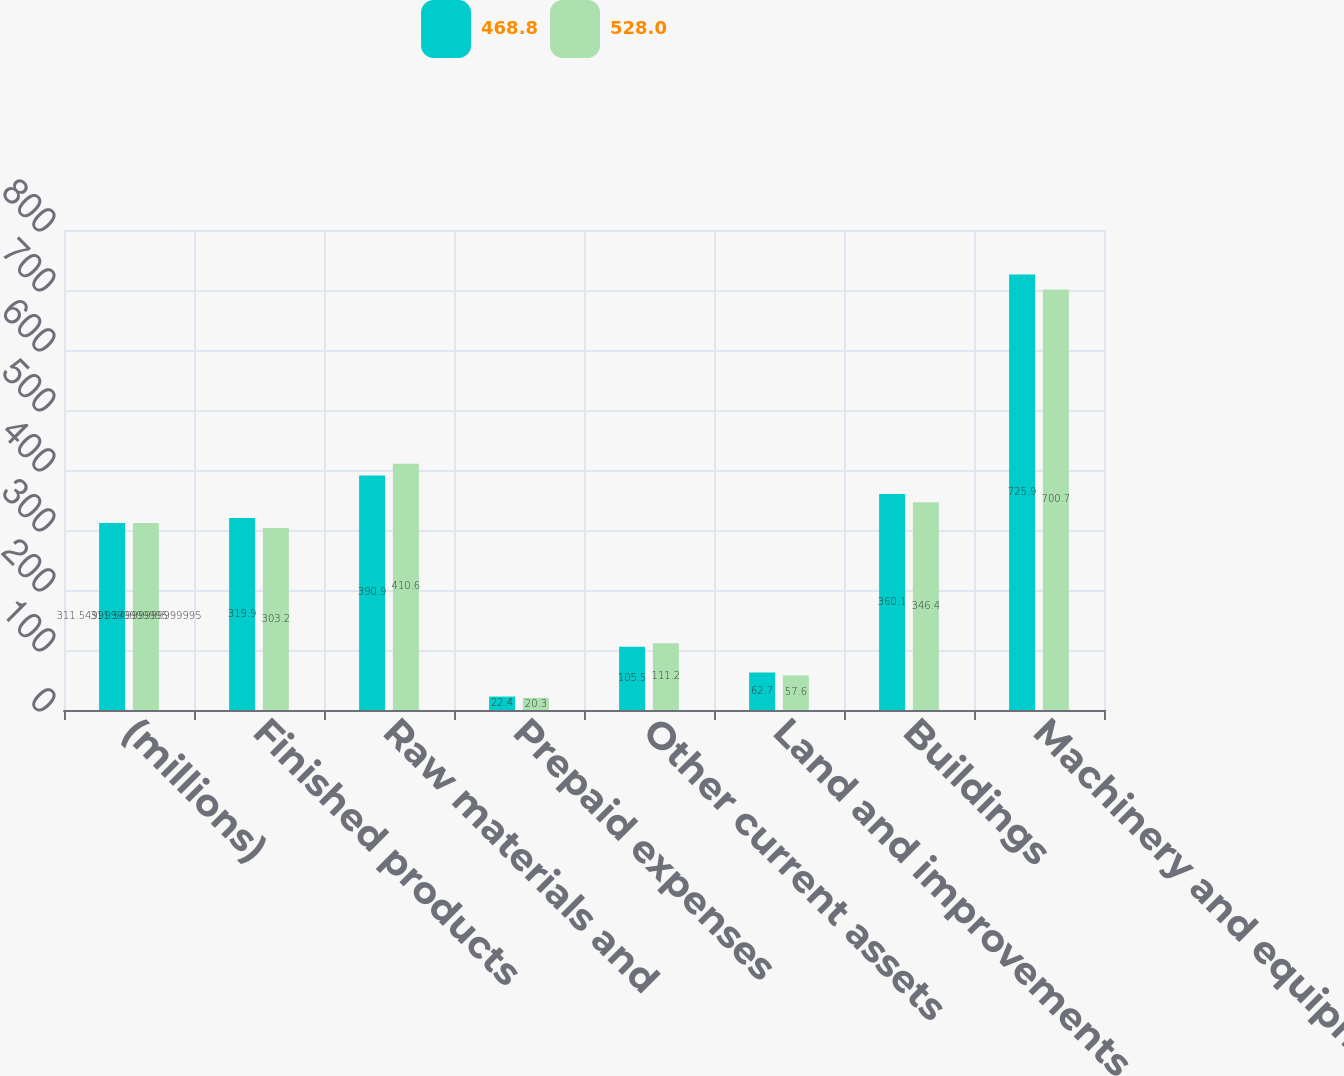Convert chart to OTSL. <chart><loc_0><loc_0><loc_500><loc_500><stacked_bar_chart><ecel><fcel>(millions)<fcel>Finished products<fcel>Raw materials and<fcel>Prepaid expenses<fcel>Other current assets<fcel>Land and improvements<fcel>Buildings<fcel>Machinery and equipment<nl><fcel>468.8<fcel>311.55<fcel>319.9<fcel>390.9<fcel>22.4<fcel>105.5<fcel>62.7<fcel>360.1<fcel>725.9<nl><fcel>528<fcel>311.55<fcel>303.2<fcel>410.6<fcel>20.3<fcel>111.2<fcel>57.6<fcel>346.4<fcel>700.7<nl></chart> 